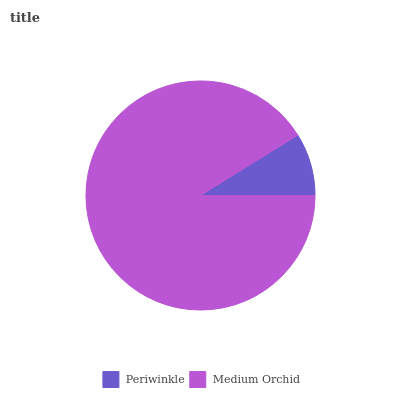Is Periwinkle the minimum?
Answer yes or no. Yes. Is Medium Orchid the maximum?
Answer yes or no. Yes. Is Medium Orchid the minimum?
Answer yes or no. No. Is Medium Orchid greater than Periwinkle?
Answer yes or no. Yes. Is Periwinkle less than Medium Orchid?
Answer yes or no. Yes. Is Periwinkle greater than Medium Orchid?
Answer yes or no. No. Is Medium Orchid less than Periwinkle?
Answer yes or no. No. Is Medium Orchid the high median?
Answer yes or no. Yes. Is Periwinkle the low median?
Answer yes or no. Yes. Is Periwinkle the high median?
Answer yes or no. No. Is Medium Orchid the low median?
Answer yes or no. No. 